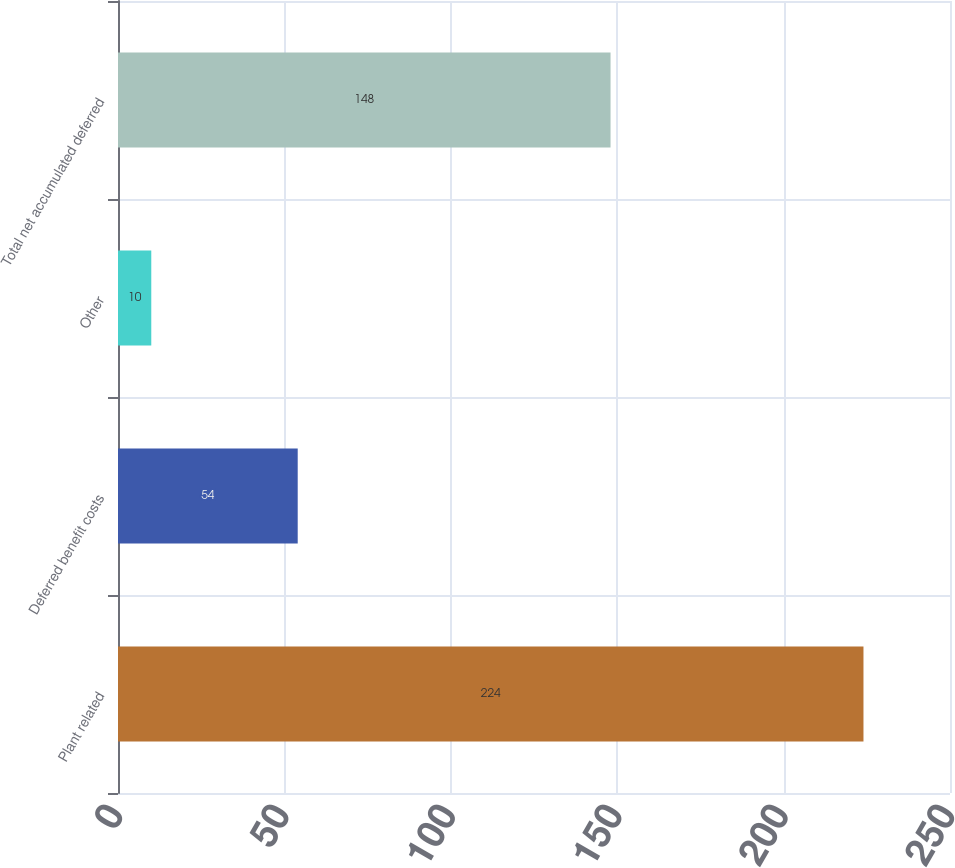<chart> <loc_0><loc_0><loc_500><loc_500><bar_chart><fcel>Plant related<fcel>Deferred benefit costs<fcel>Other<fcel>Total net accumulated deferred<nl><fcel>224<fcel>54<fcel>10<fcel>148<nl></chart> 